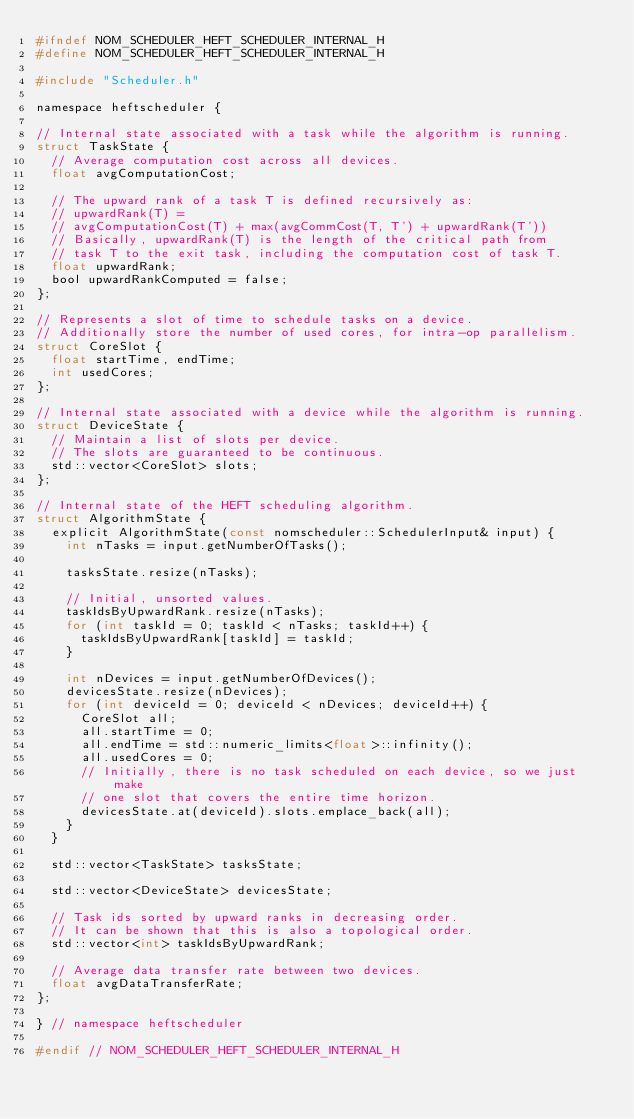<code> <loc_0><loc_0><loc_500><loc_500><_C_>#ifndef NOM_SCHEDULER_HEFT_SCHEDULER_INTERNAL_H
#define NOM_SCHEDULER_HEFT_SCHEDULER_INTERNAL_H

#include "Scheduler.h"

namespace heftscheduler {

// Internal state associated with a task while the algorithm is running.
struct TaskState {
  // Average computation cost across all devices.
  float avgComputationCost;

  // The upward rank of a task T is defined recursively as:
  // upwardRank(T) =
  // avgComputationCost(T) + max(avgCommCost(T, T') + upwardRank(T'))
  // Basically, upwardRank(T) is the length of the critical path from
  // task T to the exit task, including the computation cost of task T.
  float upwardRank;
  bool upwardRankComputed = false;
};

// Represents a slot of time to schedule tasks on a device.
// Additionally store the number of used cores, for intra-op parallelism.
struct CoreSlot {
  float startTime, endTime;
  int usedCores;
};

// Internal state associated with a device while the algorithm is running.
struct DeviceState {
  // Maintain a list of slots per device.
  // The slots are guaranteed to be continuous.
  std::vector<CoreSlot> slots;
};

// Internal state of the HEFT scheduling algorithm.
struct AlgorithmState {
  explicit AlgorithmState(const nomscheduler::SchedulerInput& input) {
    int nTasks = input.getNumberOfTasks();

    tasksState.resize(nTasks);

    // Initial, unsorted values.
    taskIdsByUpwardRank.resize(nTasks);
    for (int taskId = 0; taskId < nTasks; taskId++) {
      taskIdsByUpwardRank[taskId] = taskId;
    }

    int nDevices = input.getNumberOfDevices();
    devicesState.resize(nDevices);
    for (int deviceId = 0; deviceId < nDevices; deviceId++) {
      CoreSlot all;
      all.startTime = 0;
      all.endTime = std::numeric_limits<float>::infinity();
      all.usedCores = 0;
      // Initially, there is no task scheduled on each device, so we just make
      // one slot that covers the entire time horizon.
      devicesState.at(deviceId).slots.emplace_back(all);
    }
  }

  std::vector<TaskState> tasksState;

  std::vector<DeviceState> devicesState;

  // Task ids sorted by upward ranks in decreasing order.
  // It can be shown that this is also a topological order.
  std::vector<int> taskIdsByUpwardRank;

  // Average data transfer rate between two devices.
  float avgDataTransferRate;
};

} // namespace heftscheduler

#endif // NOM_SCHEDULER_HEFT_SCHEDULER_INTERNAL_H
</code> 